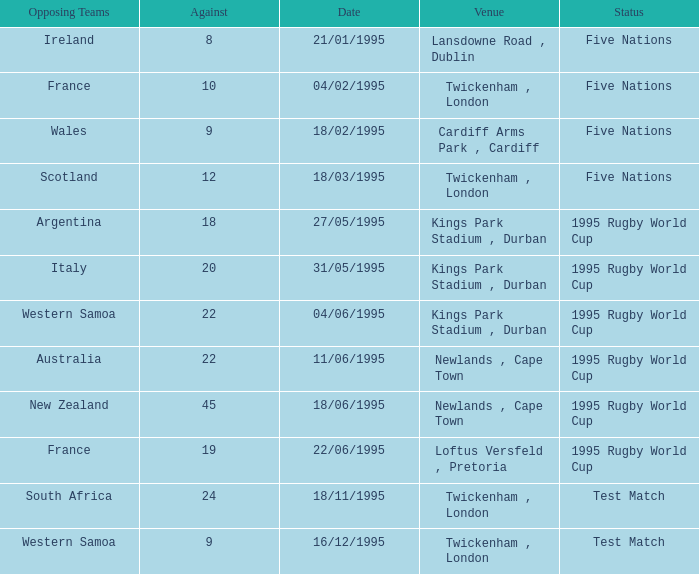What's the status with an against over 20 on 18/11/1995? Test Match. 